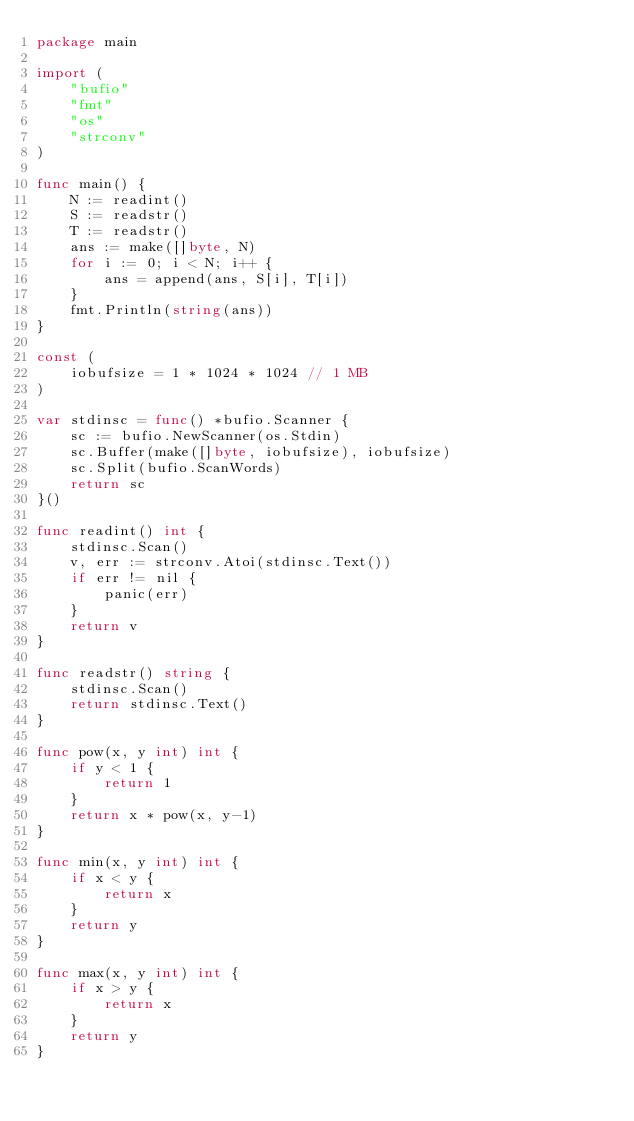Convert code to text. <code><loc_0><loc_0><loc_500><loc_500><_Go_>package main

import (
	"bufio"
	"fmt"
	"os"
	"strconv"
)

func main() {
	N := readint()
	S := readstr()
	T := readstr()
	ans := make([]byte, N)
	for i := 0; i < N; i++ {
		ans = append(ans, S[i], T[i])
	}
	fmt.Println(string(ans))
}

const (
	iobufsize = 1 * 1024 * 1024 // 1 MB
)

var stdinsc = func() *bufio.Scanner {
	sc := bufio.NewScanner(os.Stdin)
	sc.Buffer(make([]byte, iobufsize), iobufsize)
	sc.Split(bufio.ScanWords)
	return sc
}()

func readint() int {
	stdinsc.Scan()
	v, err := strconv.Atoi(stdinsc.Text())
	if err != nil {
		panic(err)
	}
	return v
}

func readstr() string {
	stdinsc.Scan()
	return stdinsc.Text()
}

func pow(x, y int) int {
	if y < 1 {
		return 1
	}
	return x * pow(x, y-1)
}

func min(x, y int) int {
	if x < y {
		return x
	}
	return y
}

func max(x, y int) int {
	if x > y {
		return x
	}
	return y
}
</code> 